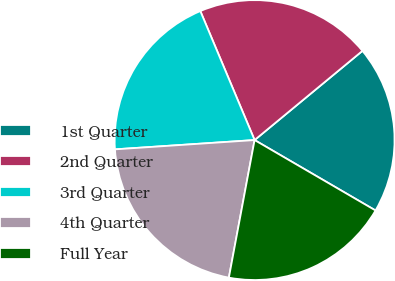<chart> <loc_0><loc_0><loc_500><loc_500><pie_chart><fcel>1st Quarter<fcel>2nd Quarter<fcel>3rd Quarter<fcel>4th Quarter<fcel>Full Year<nl><fcel>19.39%<fcel>20.34%<fcel>19.72%<fcel>21.0%<fcel>19.55%<nl></chart> 